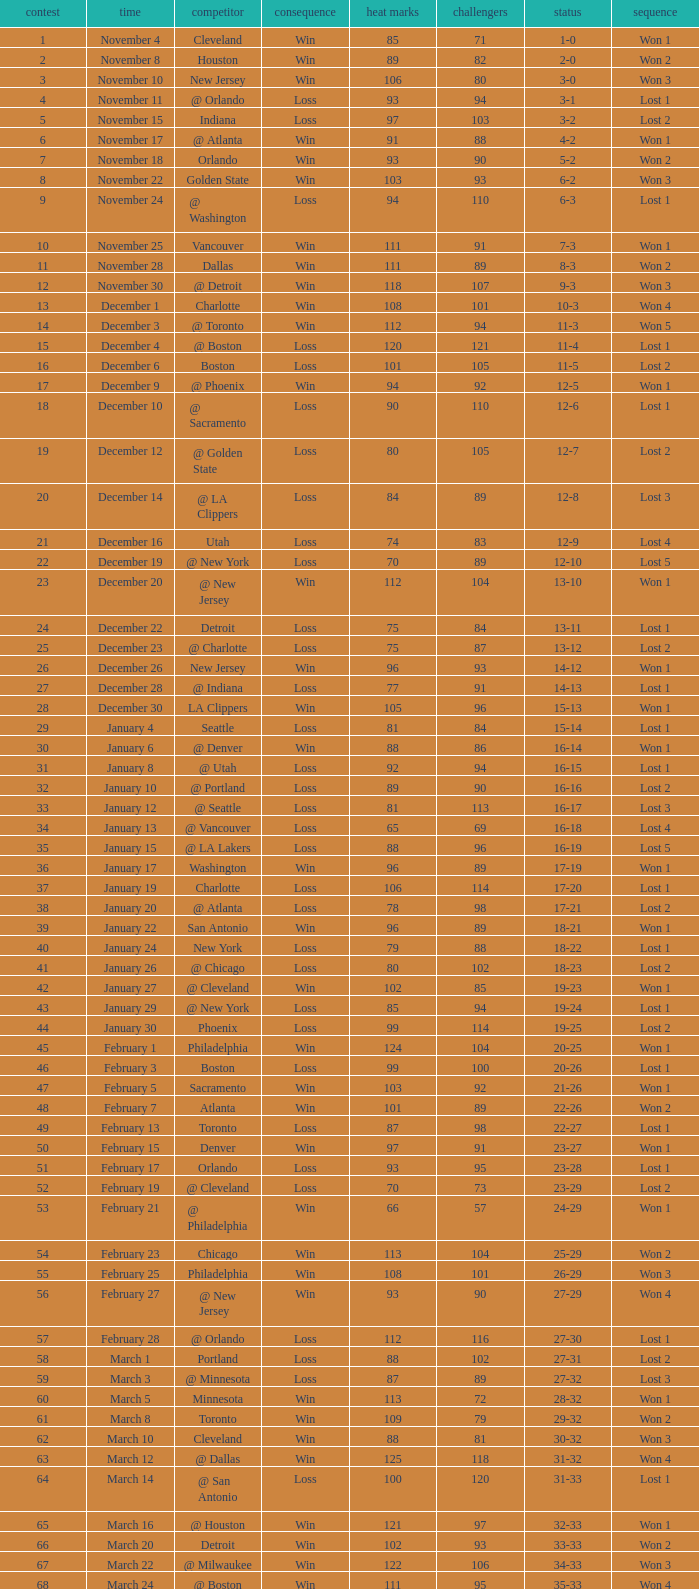What is Heat Points, when Game is less than 80, and when Date is "April 26 (First Round)"? 85.0. 